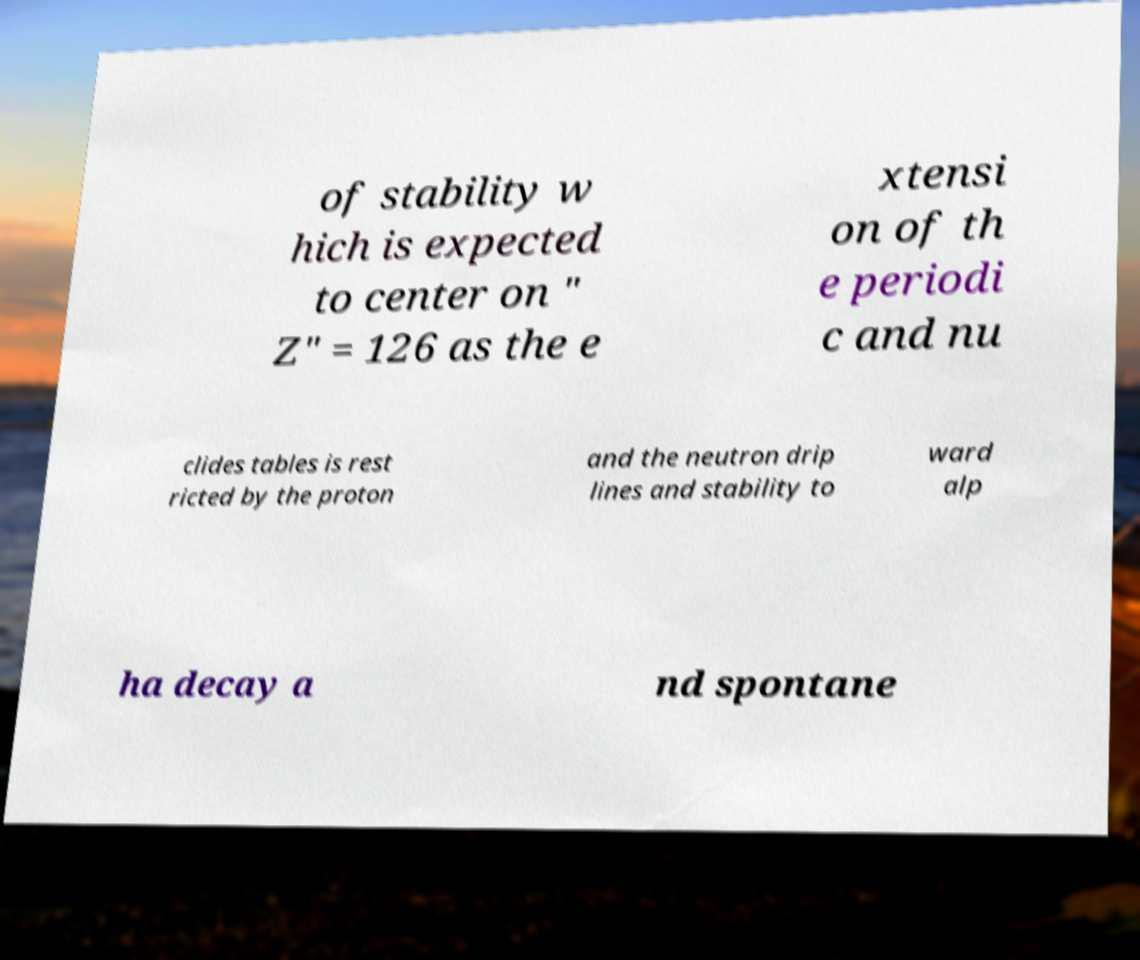What messages or text are displayed in this image? I need them in a readable, typed format. of stability w hich is expected to center on " Z" = 126 as the e xtensi on of th e periodi c and nu clides tables is rest ricted by the proton and the neutron drip lines and stability to ward alp ha decay a nd spontane 